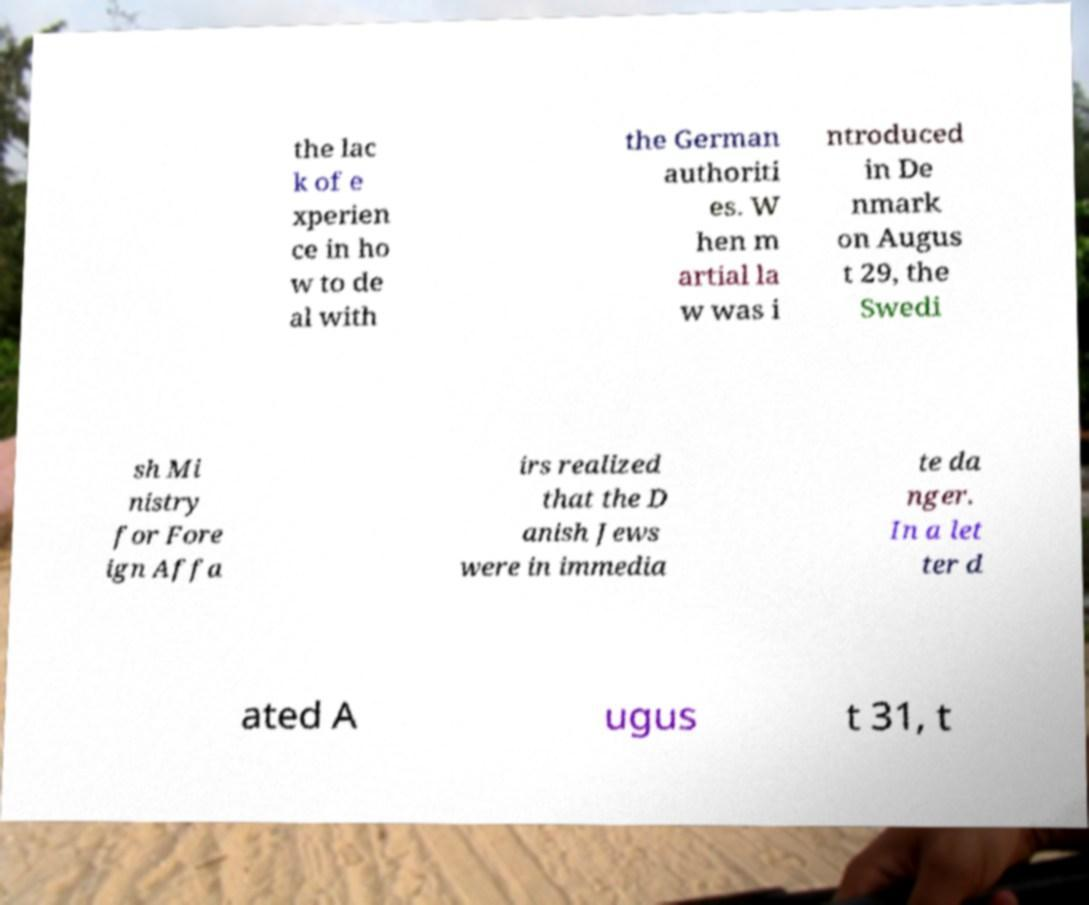Could you extract and type out the text from this image? the lac k of e xperien ce in ho w to de al with the German authoriti es. W hen m artial la w was i ntroduced in De nmark on Augus t 29, the Swedi sh Mi nistry for Fore ign Affa irs realized that the D anish Jews were in immedia te da nger. In a let ter d ated A ugus t 31, t 